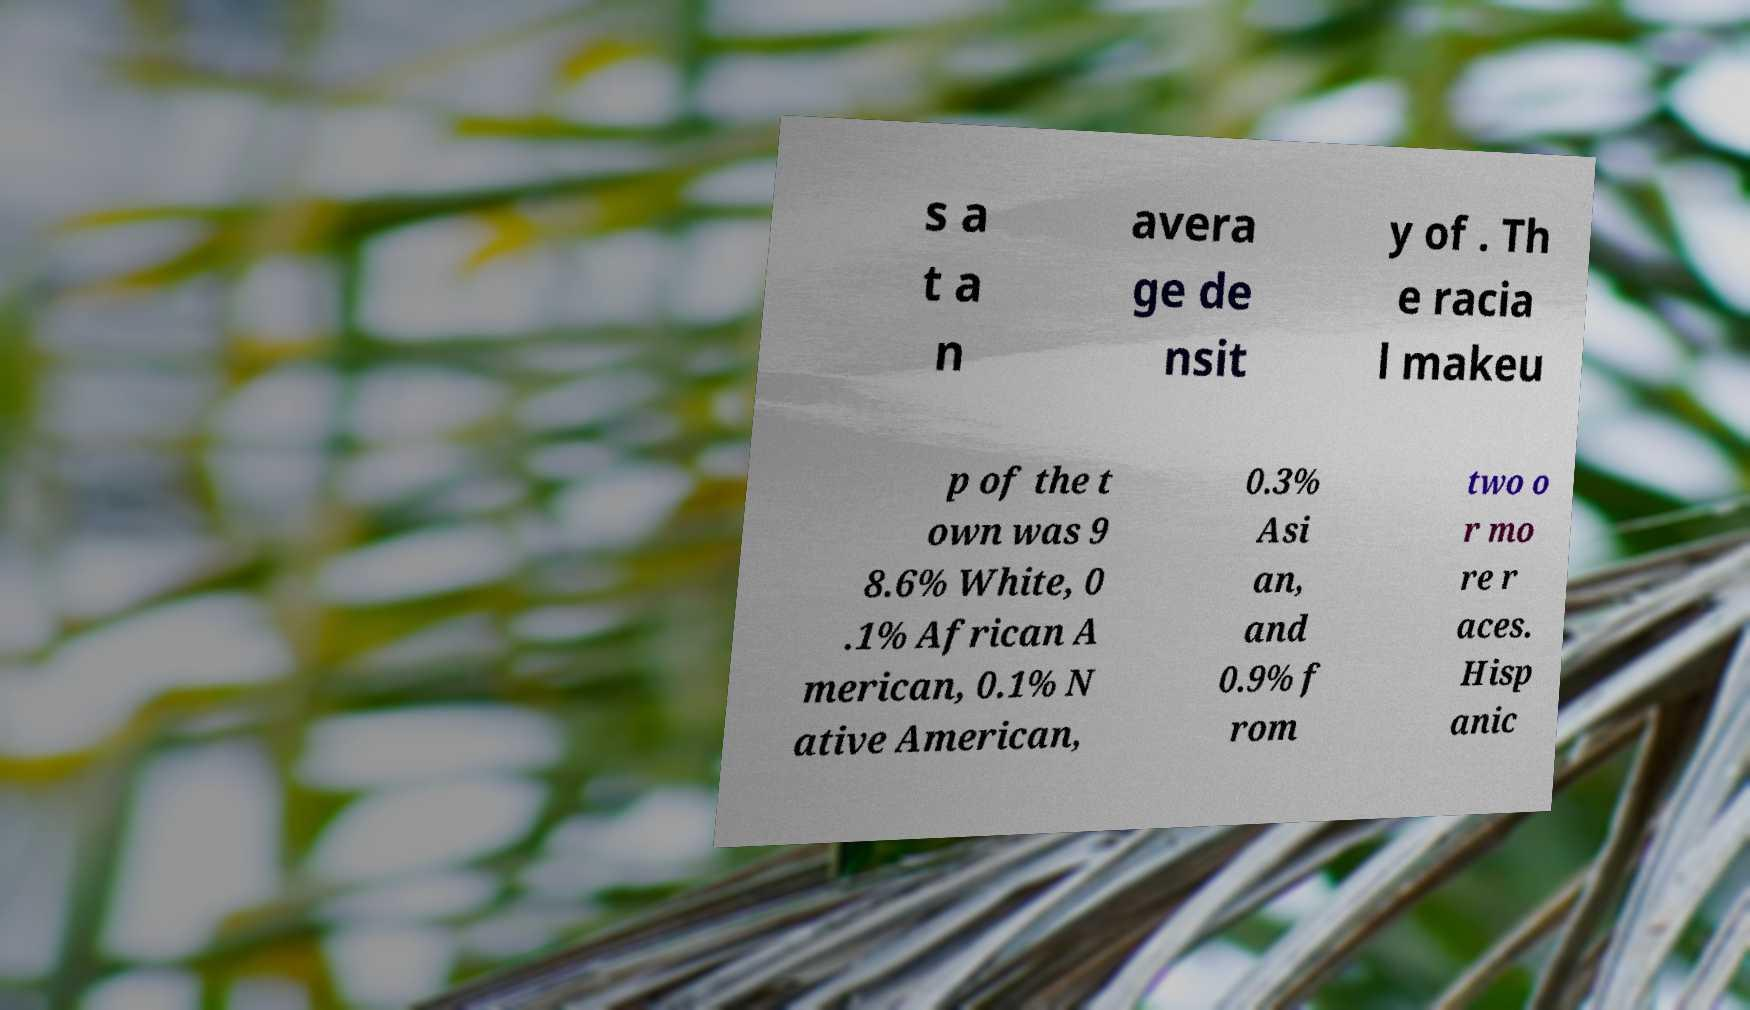Please read and relay the text visible in this image. What does it say? s a t a n avera ge de nsit y of . Th e racia l makeu p of the t own was 9 8.6% White, 0 .1% African A merican, 0.1% N ative American, 0.3% Asi an, and 0.9% f rom two o r mo re r aces. Hisp anic 